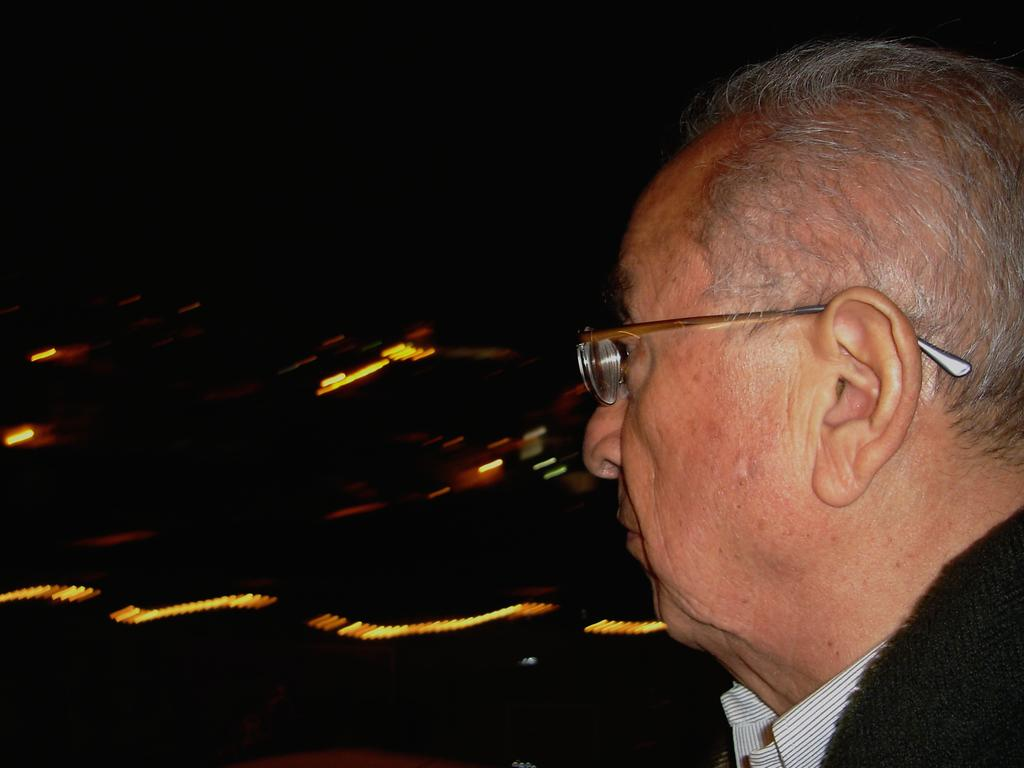Who or what is present in the image? There is a person in the image. Can you describe the person's appearance? The person is wearing spectacles. What can be seen on the left side of the image? There is a lighting on the left side of the image. How does the lighting affect the view on the left side? The view on the left side appears dark. What is the person arguing about in the image? There is no indication of an argument in the image; it only shows a person wearing spectacles with lighting on the left side. 